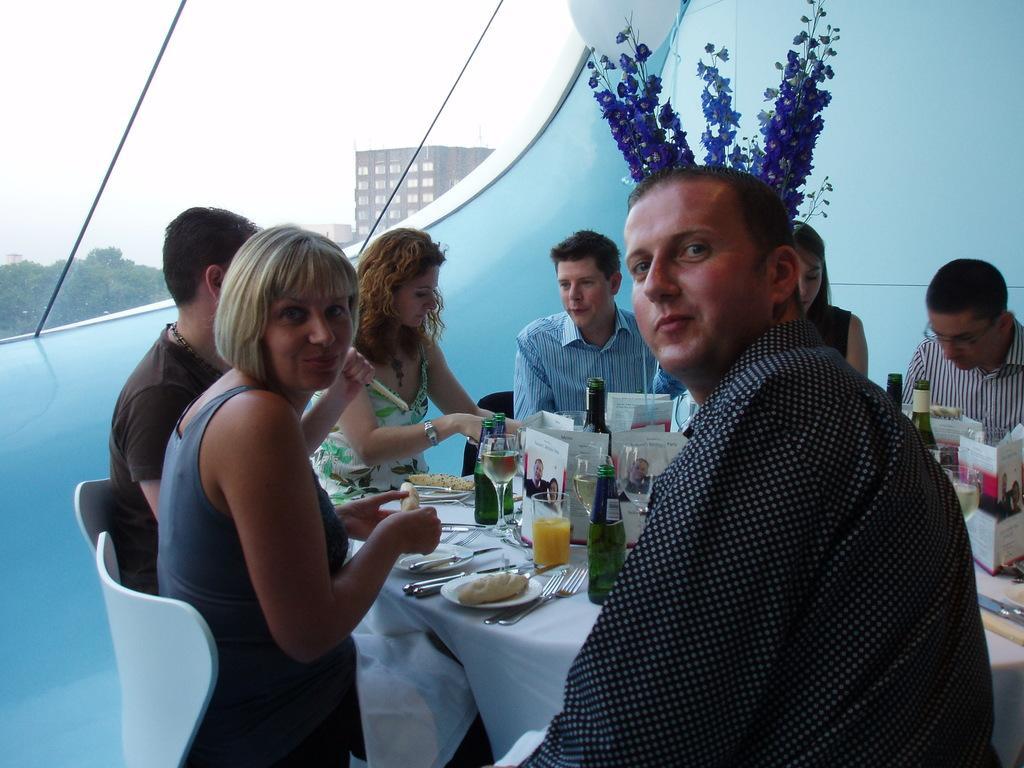Describe this image in one or two sentences. There are few people here sitting on the chair around the table. On the table we can see food items,wine bottle,glass,spoons,forks,knives. In the background we can see window,plant. 